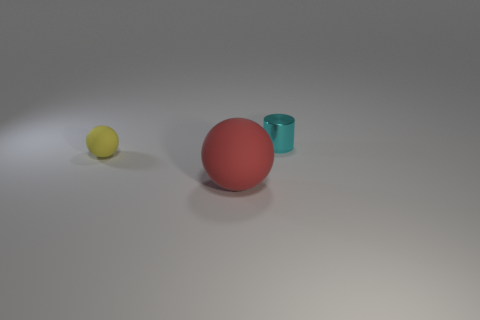How many objects are visible in the image, and can you describe them? There are three distinct objects visible in the image: a small yellow sphere, a larger red sphere, and a turquoise cylinder with open ends. The spheres appear to be made of a matte material, possibly rubber, while the cylinder has a slightly shinier appearance, indicating it might be made of plastic or metal. 